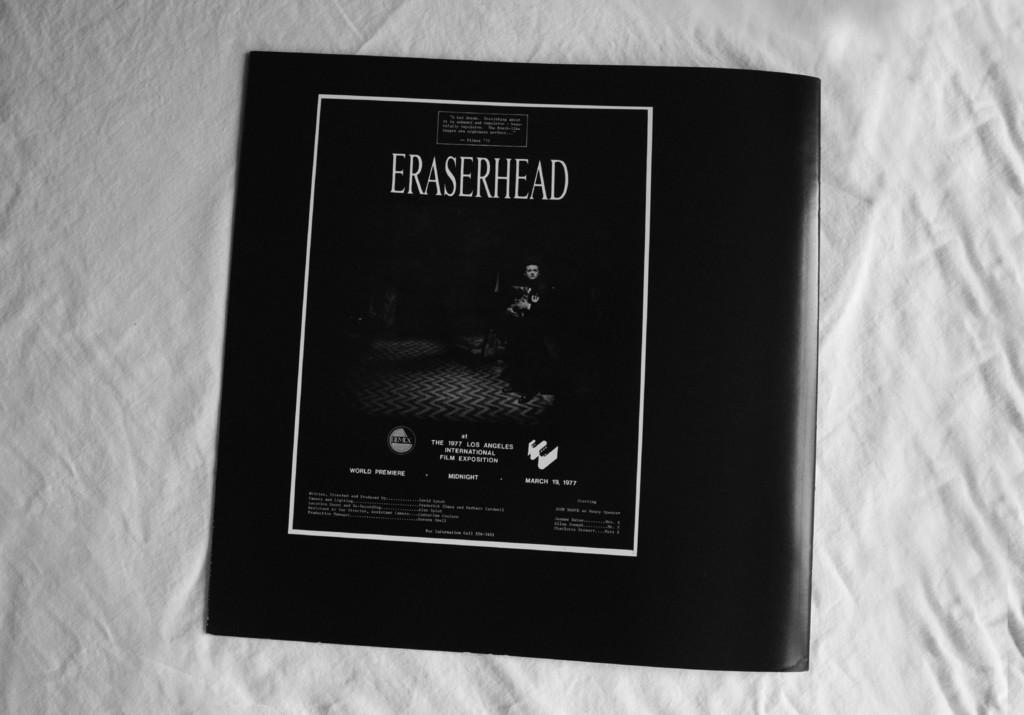<image>
Offer a succinct explanation of the picture presented. The front of some sort of packaging that reads ERASERHEAD. 